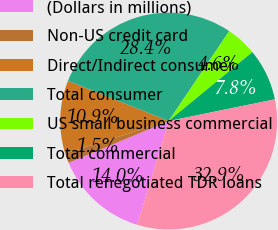Convert chart. <chart><loc_0><loc_0><loc_500><loc_500><pie_chart><fcel>(Dollars in millions)<fcel>Non-US credit card<fcel>Direct/Indirect consumer<fcel>Total consumer<fcel>US small business commercial<fcel>Total commercial<fcel>Total renegotiated TDR loans<nl><fcel>14.03%<fcel>1.47%<fcel>10.89%<fcel>28.37%<fcel>4.61%<fcel>7.75%<fcel>32.88%<nl></chart> 